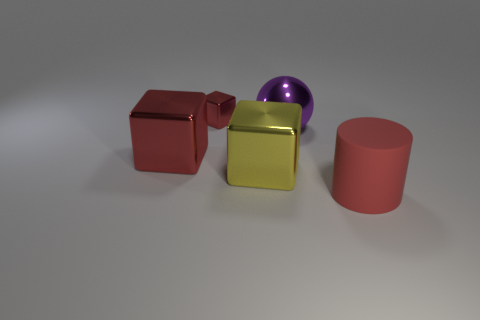Subtract all big blocks. How many blocks are left? 1 Add 1 purple spheres. How many objects exist? 6 Subtract all blocks. How many objects are left? 2 Subtract all large purple objects. Subtract all metallic blocks. How many objects are left? 1 Add 2 yellow metallic objects. How many yellow metallic objects are left? 3 Add 4 large red objects. How many large red objects exist? 6 Subtract 0 brown spheres. How many objects are left? 5 